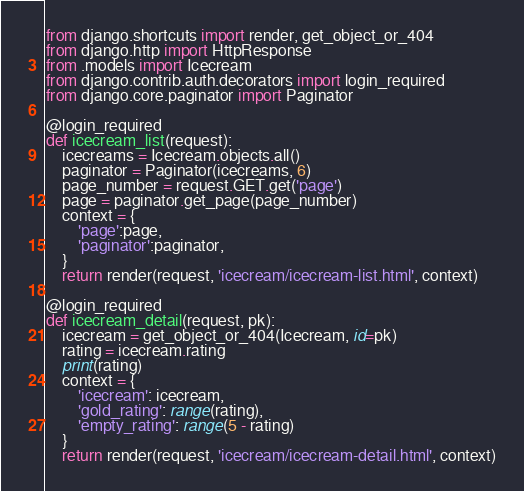<code> <loc_0><loc_0><loc_500><loc_500><_Python_>from django.shortcuts import render, get_object_or_404
from django.http import HttpResponse
from .models import Icecream
from django.contrib.auth.decorators import login_required
from django.core.paginator import Paginator

@login_required
def icecream_list(request):
    icecreams = Icecream.objects.all()
    paginator = Paginator(icecreams, 6)
    page_number = request.GET.get('page')
    page = paginator.get_page(page_number)
    context = {
        'page':page,
        'paginator':paginator,
    }
    return render(request, 'icecream/icecream-list.html', context)

@login_required
def icecream_detail(request, pk):
    icecream = get_object_or_404(Icecream, id=pk)
    rating = icecream.rating
    print(rating)
    context = {
        'icecream': icecream,
        'gold_rating': range(rating),
        'empty_rating': range(5 - rating)
    }
    return render(request, 'icecream/icecream-detail.html', context)</code> 